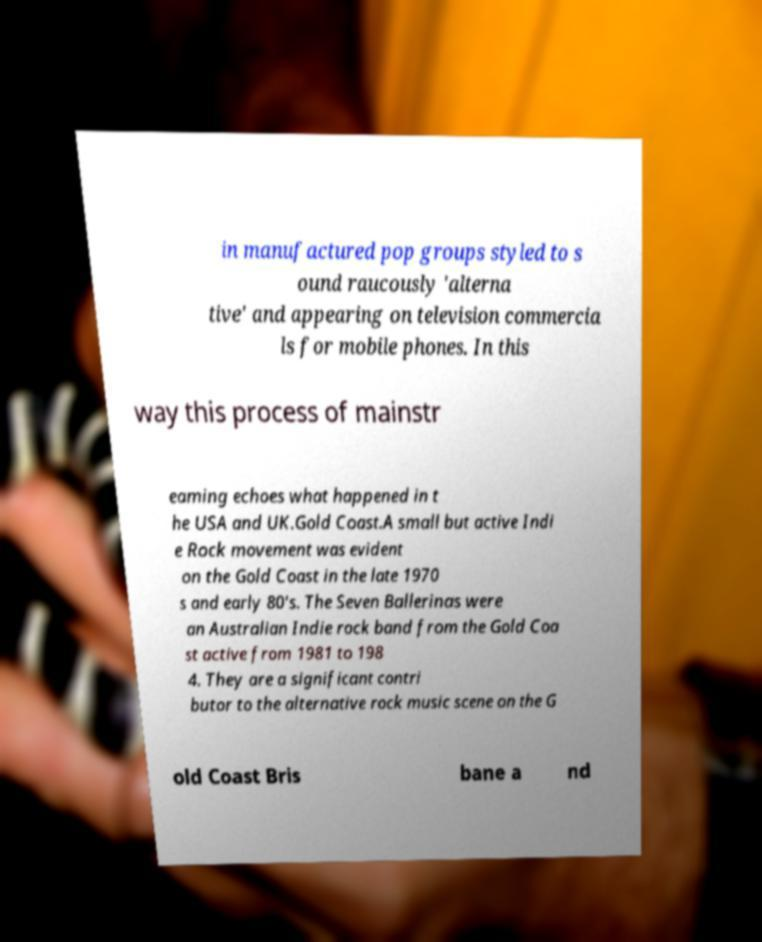What messages or text are displayed in this image? I need them in a readable, typed format. in manufactured pop groups styled to s ound raucously 'alterna tive' and appearing on television commercia ls for mobile phones. In this way this process of mainstr eaming echoes what happened in t he USA and UK.Gold Coast.A small but active Indi e Rock movement was evident on the Gold Coast in the late 1970 s and early 80's. The Seven Ballerinas were an Australian Indie rock band from the Gold Coa st active from 1981 to 198 4. They are a significant contri butor to the alternative rock music scene on the G old Coast Bris bane a nd 